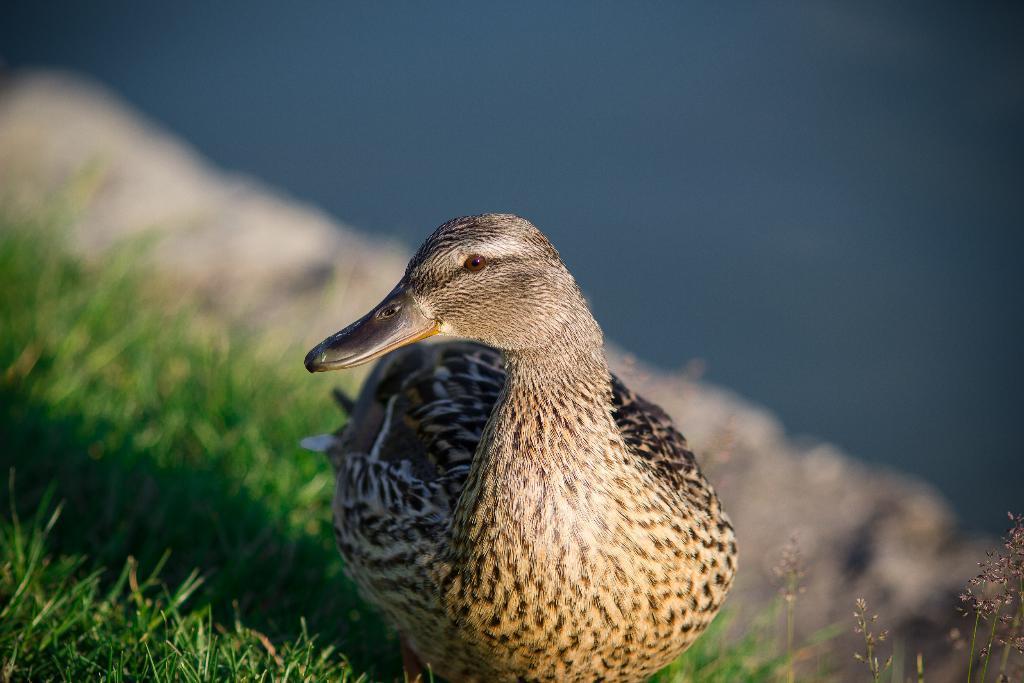Describe this image in one or two sentences. In this picture we can see a bird, here we can see the grass and in the background we can see it is blurry. 